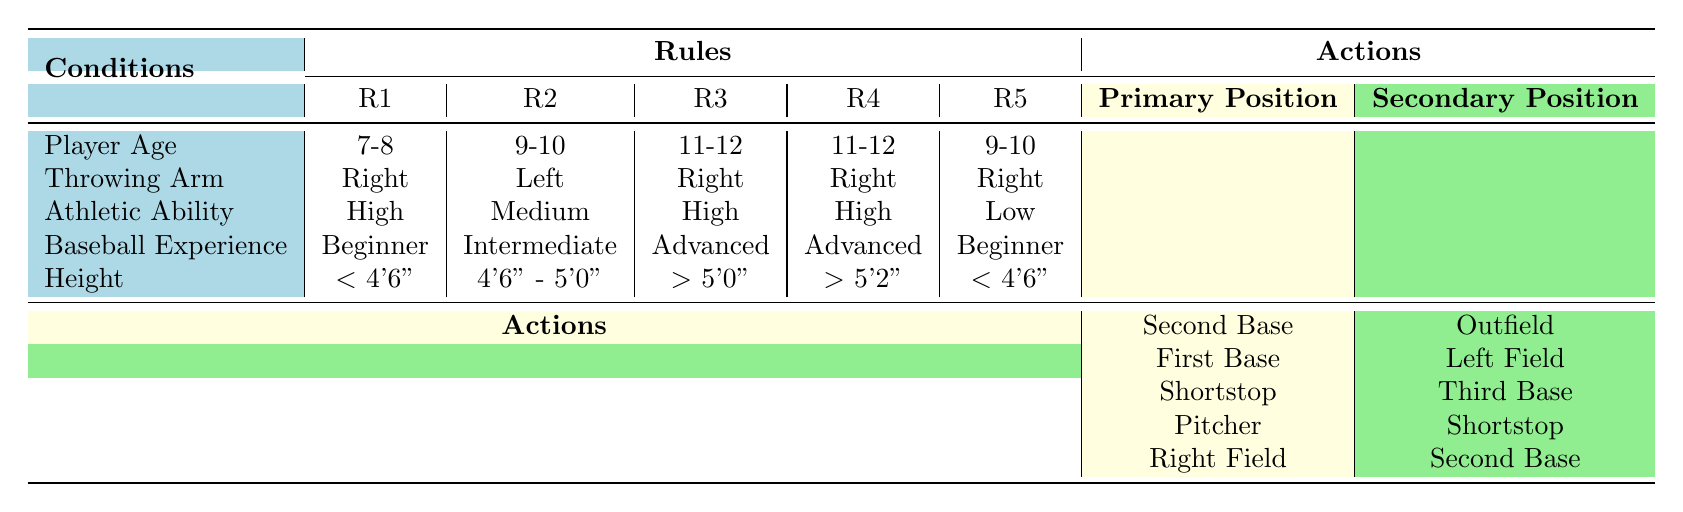What is the primary position for a right-handed, 11-12 year old player with high athletic ability and advanced baseball experience over 5'2"? Referring to the table, we find the row that matches the conditions: Player Age is "11-12", Throwing Arm is "Right", Athletic Ability is "High", Baseball Experience is "Advanced", and Height is "> 5'2\"". This corresponds to rule R4, which assigns "Pitcher" as the primary position.
Answer: Pitcher For a 9-10 year old right-handed player with low athletic ability and beginner experience under 4'6", what is the secondary position? Looking for a 9-10 year old, right-handed player with low athletic ability, beginner experience, and height under 4'6", we find rule R5. The secondary position listed there is "Second Base".
Answer: Second Base Is there a primary position assigned for 7-8 year old left-handed players? Checking the table, we see that the only left-handed player matching the age of 7-8 is listed in rule R6, which assigns "Left Field" as the primary position. Therefore, the statement is true.
Answer: Yes What is the average height range for players who are assigned as first basemen? The conditions for players assigned as "First Base" are found in rules R2 and R7. R2 specifies the height range of "4'6\" - 5'0\"", and R7 specifies "< 4'6\"". Thus, the average of 4'6" (4.5 feet) to 5'0" (5 feet) combined with less than 4'6" means the average height range is not specifically calculable in a conventional sense since "< 4'6\"" represents various values.
Answer: The average height range cannot be established What are the primary and secondary positions for right-handed players aged 9-10 with high athletic ability and advanced baseball experience? Parsing through the table, we look for the rule based on Player Age "9-10", Throwing Arm "Right", Athletic Ability "High", and Baseball Experience "Advanced". There is no specific entry meeting all those criteria, indicating that no positions are assigned under these conditions.
Answer: No positions assigned 